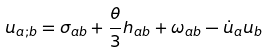Convert formula to latex. <formula><loc_0><loc_0><loc_500><loc_500>u _ { a ; b } = \sigma _ { a b } + \frac { \theta } { 3 } h _ { a b } + \omega _ { a b } - \dot { u } _ { a } u _ { b }</formula> 